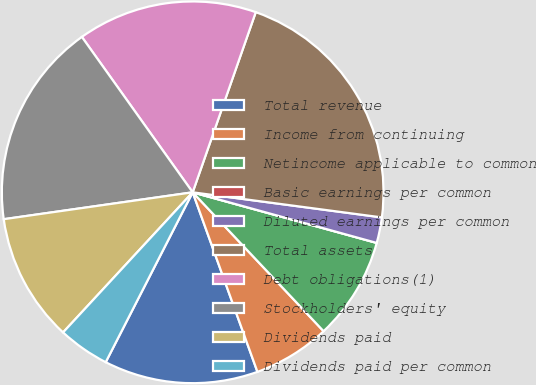Convert chart. <chart><loc_0><loc_0><loc_500><loc_500><pie_chart><fcel>Total revenue<fcel>Income from continuing<fcel>Netincome applicable to common<fcel>Basic earnings per common<fcel>Diluted earnings per common<fcel>Total assets<fcel>Debt obligations(1)<fcel>Stockholders' equity<fcel>Dividends paid<fcel>Dividends paid per common<nl><fcel>13.04%<fcel>6.52%<fcel>8.7%<fcel>0.0%<fcel>2.17%<fcel>21.74%<fcel>15.22%<fcel>17.39%<fcel>10.87%<fcel>4.35%<nl></chart> 